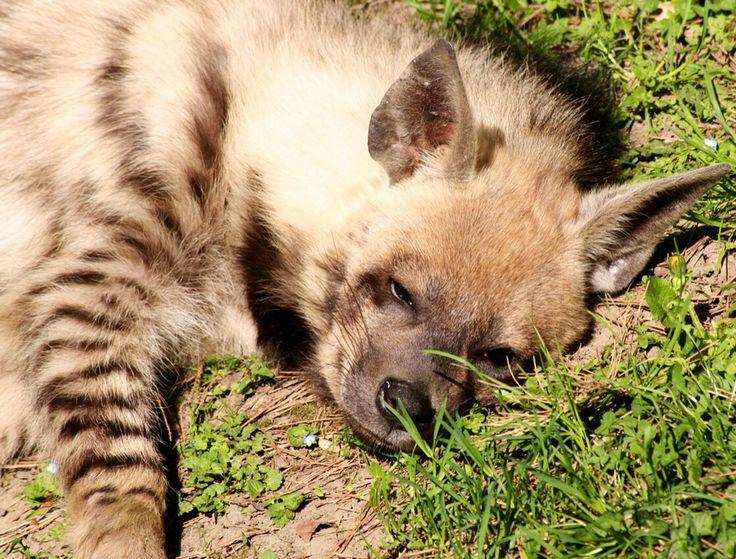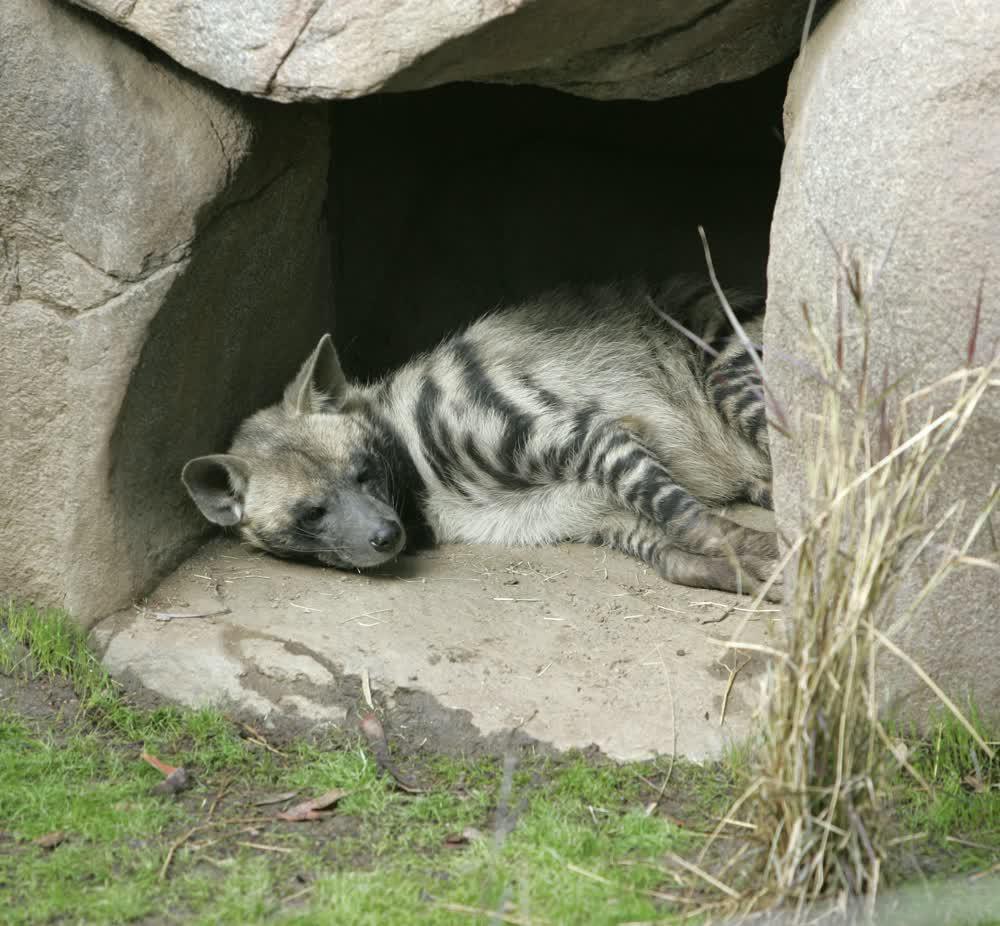The first image is the image on the left, the second image is the image on the right. Analyze the images presented: Is the assertion "At least one animal is resting underneath of a rocky covering." valid? Answer yes or no. Yes. 